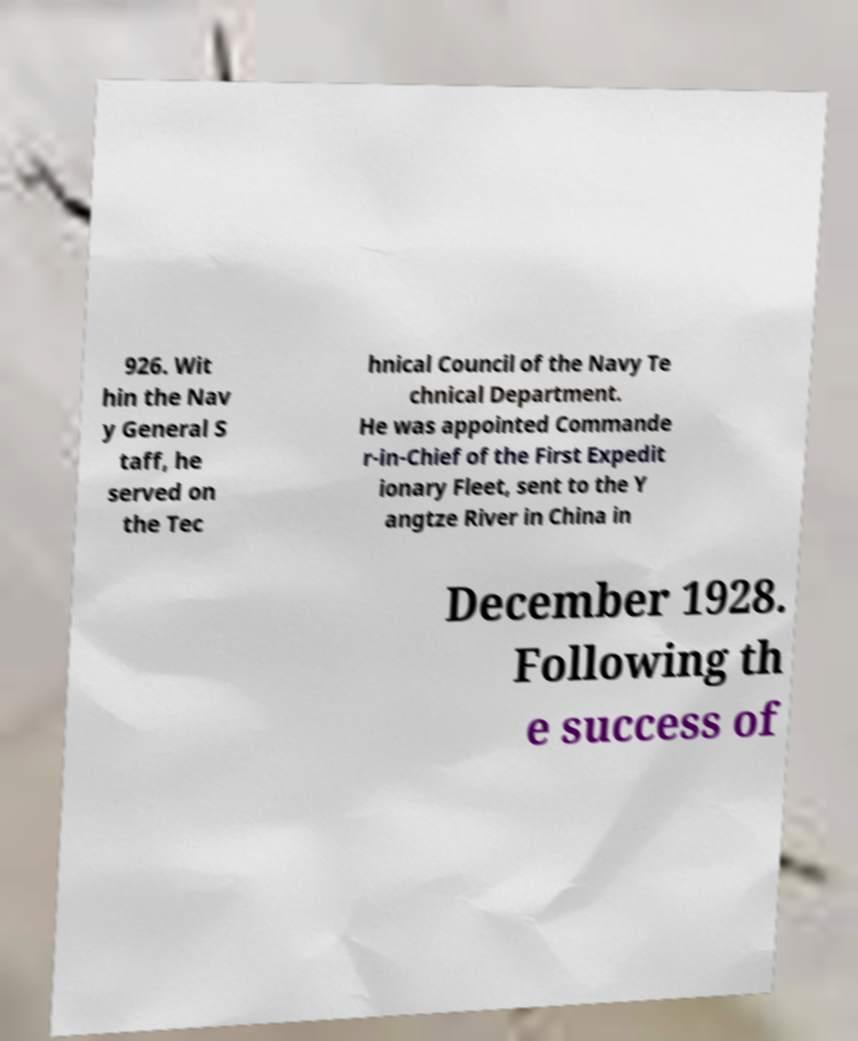I need the written content from this picture converted into text. Can you do that? 926. Wit hin the Nav y General S taff, he served on the Tec hnical Council of the Navy Te chnical Department. He was appointed Commande r-in-Chief of the First Expedit ionary Fleet, sent to the Y angtze River in China in December 1928. Following th e success of 